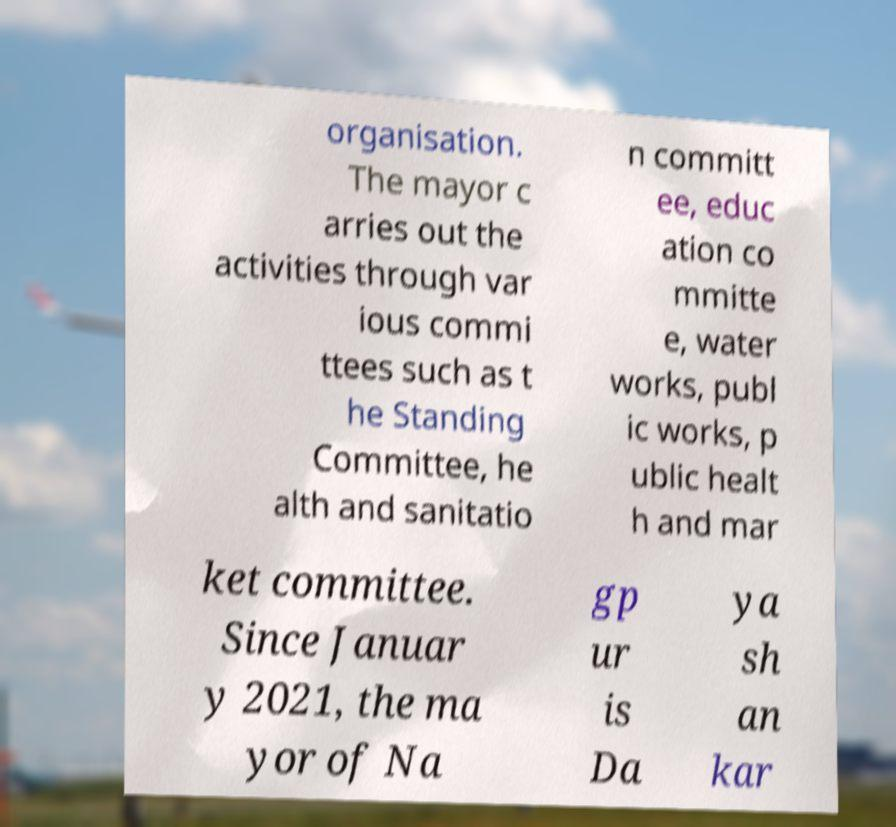For documentation purposes, I need the text within this image transcribed. Could you provide that? organisation. The mayor c arries out the activities through var ious commi ttees such as t he Standing Committee, he alth and sanitatio n committ ee, educ ation co mmitte e, water works, publ ic works, p ublic healt h and mar ket committee. Since Januar y 2021, the ma yor of Na gp ur is Da ya sh an kar 